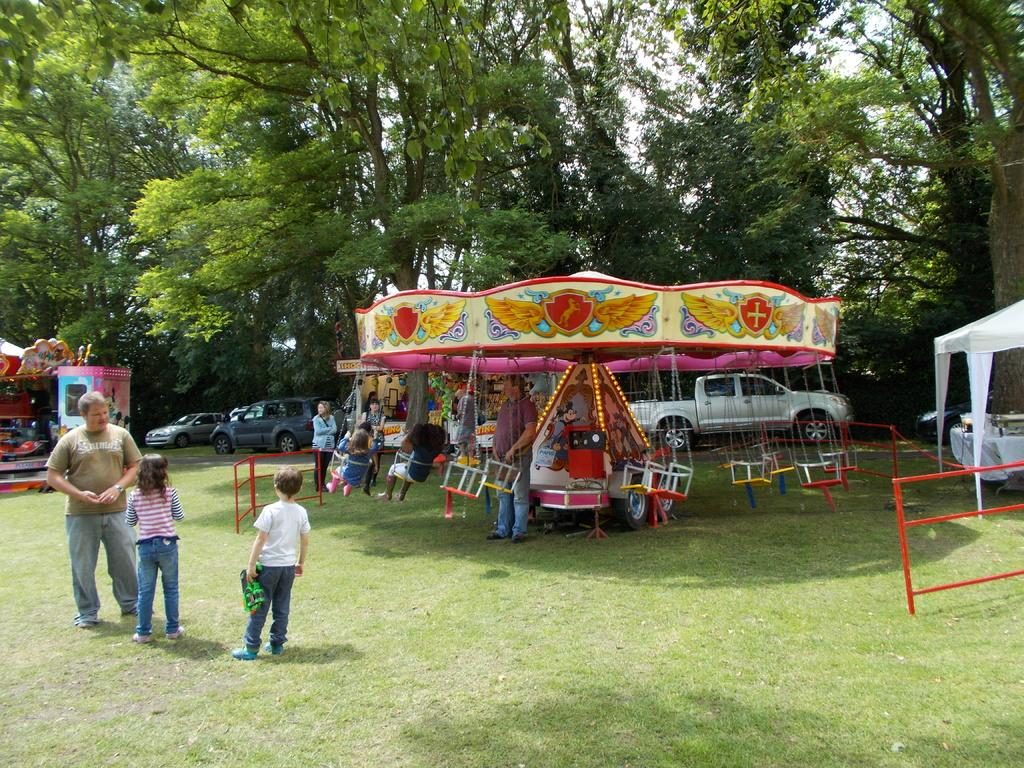What is the main subject in the image? There is a carousel in the image. Who else is present in the image besides the carousel? There is a man and two kids in the image. Where are the man and kids standing in the image? The man and kids are standing on the grass. What can be seen in the background of the image? There are trees in the background of the image. What type of grip does the carousel have on the kids in the image? The image does not show any indication of a grip on the kids by the carousel. The kids are simply standing on the grass near the carousel. 